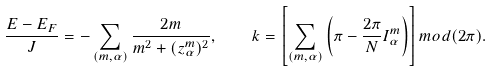Convert formula to latex. <formula><loc_0><loc_0><loc_500><loc_500>\frac { E - E _ { F } } { J } = - \sum _ { ( m , \alpha ) } \frac { 2 m } { m ^ { 2 } + ( z _ { \alpha } ^ { m } ) ^ { 2 } } , \quad k = \left [ \sum _ { ( m , \alpha ) } \left ( \pi - \frac { 2 \pi } { N } I _ { \alpha } ^ { m } \right ) \right ] m o d ( 2 \pi ) .</formula> 